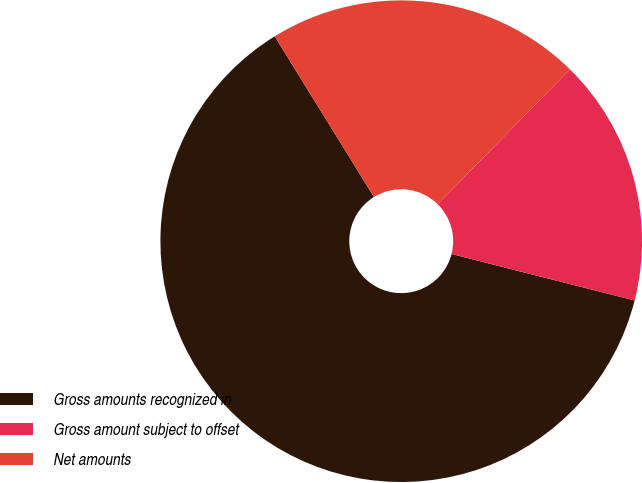Convert chart to OTSL. <chart><loc_0><loc_0><loc_500><loc_500><pie_chart><fcel>Gross amounts recognized in<fcel>Gross amount subject to offset<fcel>Net amounts<nl><fcel>62.23%<fcel>16.6%<fcel>21.16%<nl></chart> 